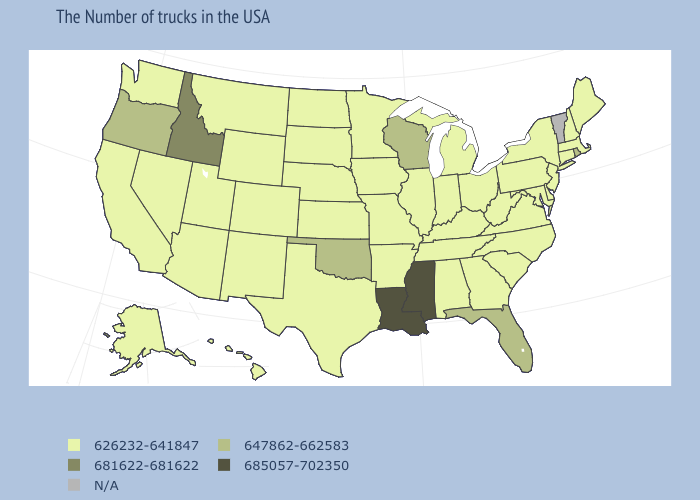What is the lowest value in states that border Mississippi?
Be succinct. 626232-641847. Which states hav the highest value in the South?
Be succinct. Mississippi, Louisiana. What is the value of Alaska?
Keep it brief. 626232-641847. What is the highest value in the West ?
Write a very short answer. 681622-681622. What is the value of Colorado?
Be succinct. 626232-641847. Name the states that have a value in the range 647862-662583?
Give a very brief answer. Rhode Island, Florida, Wisconsin, Oklahoma, Oregon. What is the value of Ohio?
Give a very brief answer. 626232-641847. Does Louisiana have the highest value in the USA?
Quick response, please. Yes. Among the states that border South Carolina , which have the lowest value?
Keep it brief. North Carolina, Georgia. What is the lowest value in the USA?
Be succinct. 626232-641847. How many symbols are there in the legend?
Give a very brief answer. 5. Which states have the highest value in the USA?
Be succinct. Mississippi, Louisiana. Among the states that border Oklahoma , which have the lowest value?
Quick response, please. Missouri, Arkansas, Kansas, Texas, Colorado, New Mexico. Name the states that have a value in the range 681622-681622?
Be succinct. Idaho. 